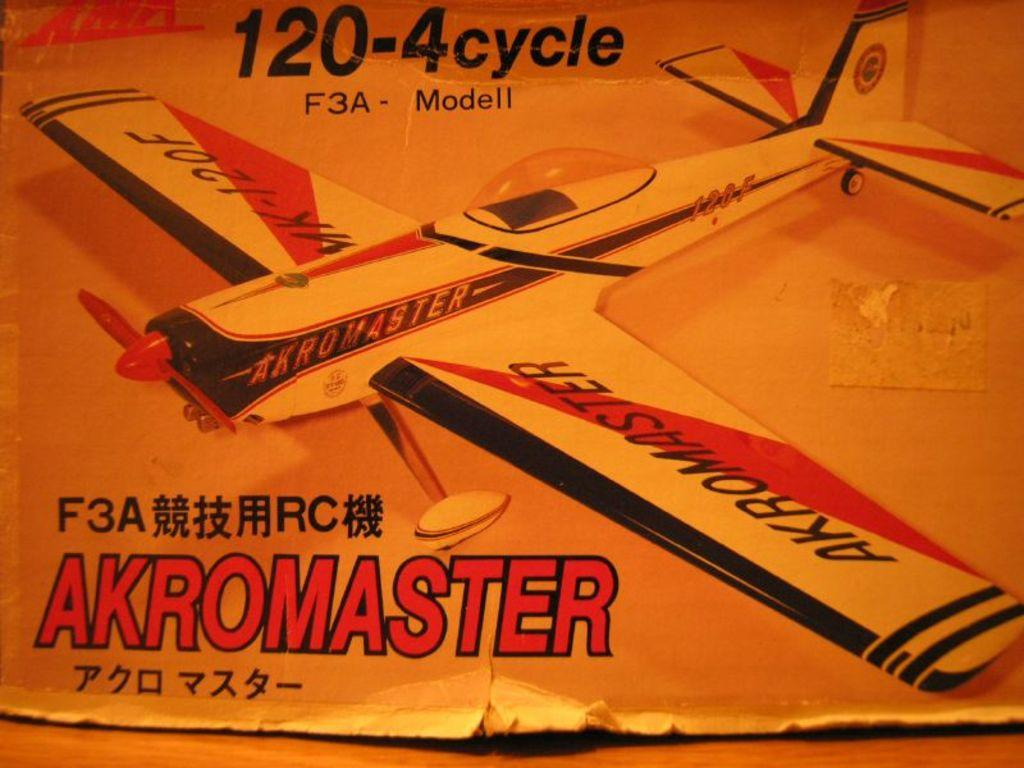<image>
Relay a brief, clear account of the picture shown. A worn japanese paper showing a picture of a plane called akromaster. 